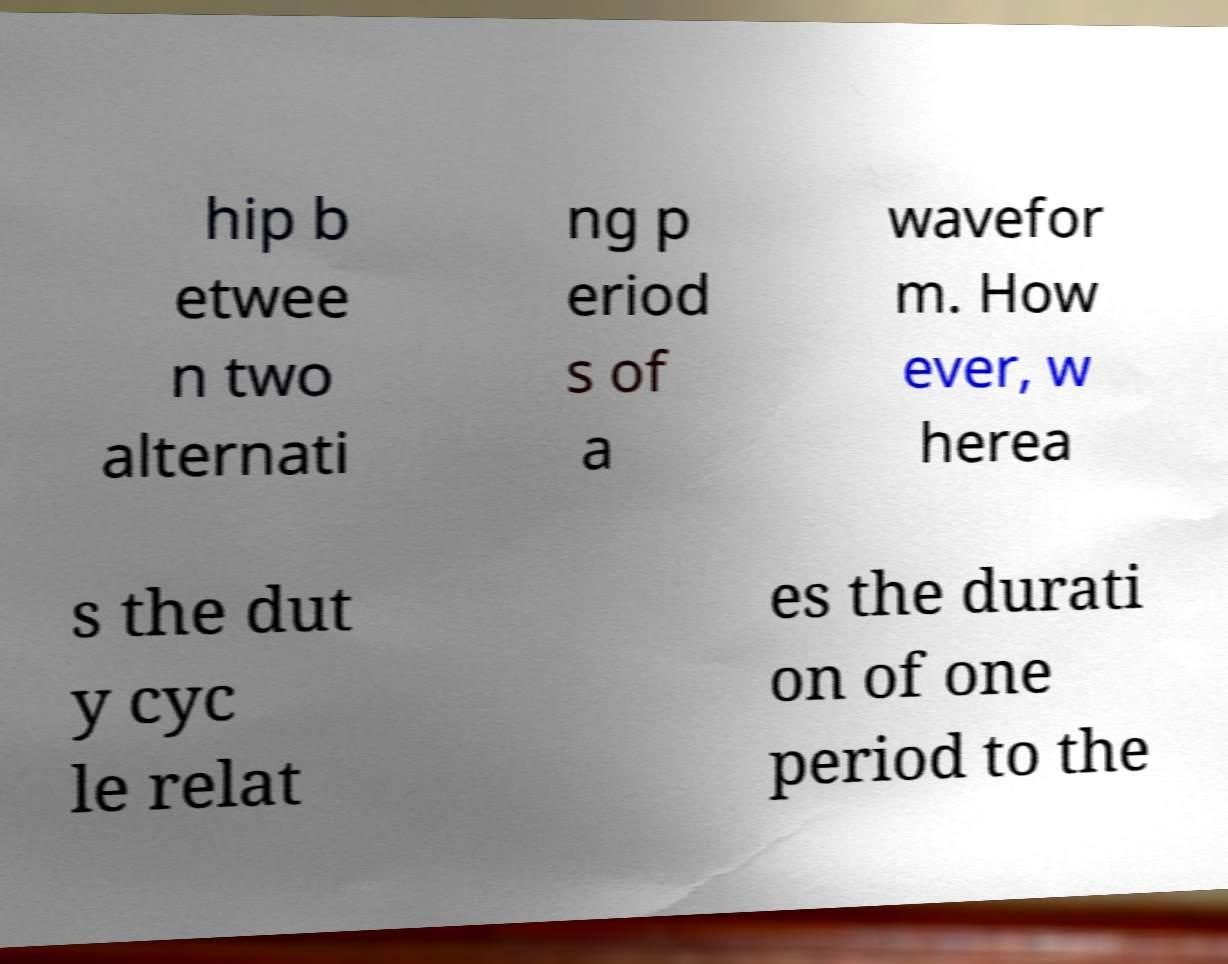Please identify and transcribe the text found in this image. hip b etwee n two alternati ng p eriod s of a wavefor m. How ever, w herea s the dut y cyc le relat es the durati on of one period to the 